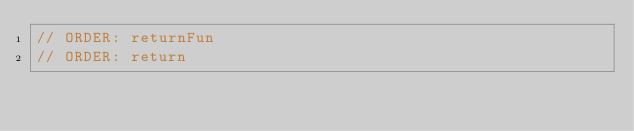Convert code to text. <code><loc_0><loc_0><loc_500><loc_500><_Kotlin_>// ORDER: returnFun
// ORDER: return
</code> 